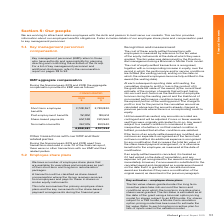According to Iselect's financial document, What is the short-term employee benefits in 2019? According to the financial document, 3,728,367. The relevant text states: "Short-term employee benefits 3,728,367 2,780,820..." Also, What is the post-employment benefits in 2018? According to the financial document, 184,614. The relevant text states: "Post-employment benefits 151,851 184,614..." Also, What is the share-based payments in 2019? According to the financial document, 651,748. The relevant text states: "Share-based payments 651,748 320,560..." Also, can you calculate: What is the percentage change in short-term employee benefits from 2018 to 2019? To answer this question, I need to perform calculations using the financial data. The calculation is: (3,728,367-2,780,820)/2,780,820, which equals 34.07 (percentage). This is based on the information: "Short-term employee benefits 3,728,367 2,780,820 Short-term employee benefits 3,728,367 2,780,820..." The key data points involved are: 2,780,820, 3,728,367. Also, can you calculate: What is the percentage change in the post-employment benefits from 2018 to 2019? To answer this question, I need to perform calculations using the financial data. The calculation is: (151,851-184,614)/184,614, which equals -17.75 (percentage). This is based on the information: "Post-employment benefits 151,851 184,614 Post-employment benefits 151,851 184,614..." The key data points involved are: 151,851, 184,614. Also, can you calculate: What is the percentage change in the termination benefits from 2018 to 2019? To answer this question, I need to perform calculations using the financial data. The calculation is: (367,015-841,940)/841,940, which equals -56.41 (percentage). This is based on the information: "Termination benefits 367,015 841,940 Termination benefits 367,015 841,940..." The key data points involved are: 367,015, 841,940. 